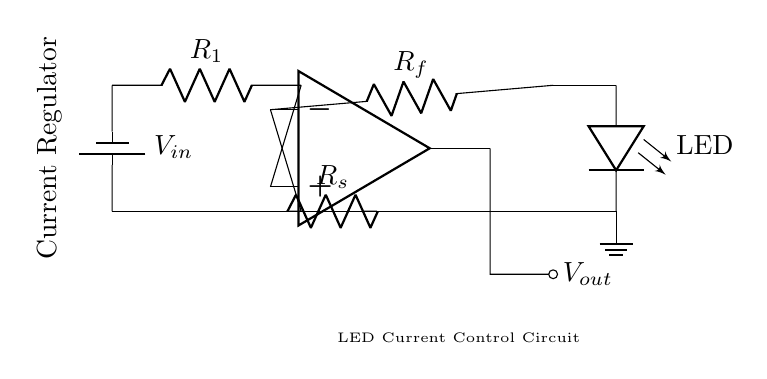What is the input voltage in this circuit? The input voltage is marked as V_in in the circuit diagram. It is the voltage supplied to the circuit, coming from the battery.
Answer: V_in What is the purpose of the feedback resistor? The feedback resistor, labeled as R_f, helps to control the feedback path in the circuit, which stabilizes the current flowing through the LED by providing negative feedback to the op-amp.
Answer: Control LED current What is the function of the sense resistor? The sense resistor, labeled as R_s, is used to measure the current through the circuit by developing a voltage drop that the op-amp can use to regulate the output current effectively.
Answer: Measure current How is the LED connected in this circuit? The LED is connected in series with the feedback resistor, creating a path for the current regulated by the op-amp to flow through it.
Answer: Series with feedback resistor What effect does the op-amp have on the LED current? The op-amp regulates the current through the LED by adjusting its output based on the voltage across the sense resistor, ensuring the LED operates at a constant current level.
Answer: Regulates current What type of circuit is this? This is a current regulator circuit designed for controlling the current flow specifically for LED lighting applications.
Answer: Current regulator circuit 